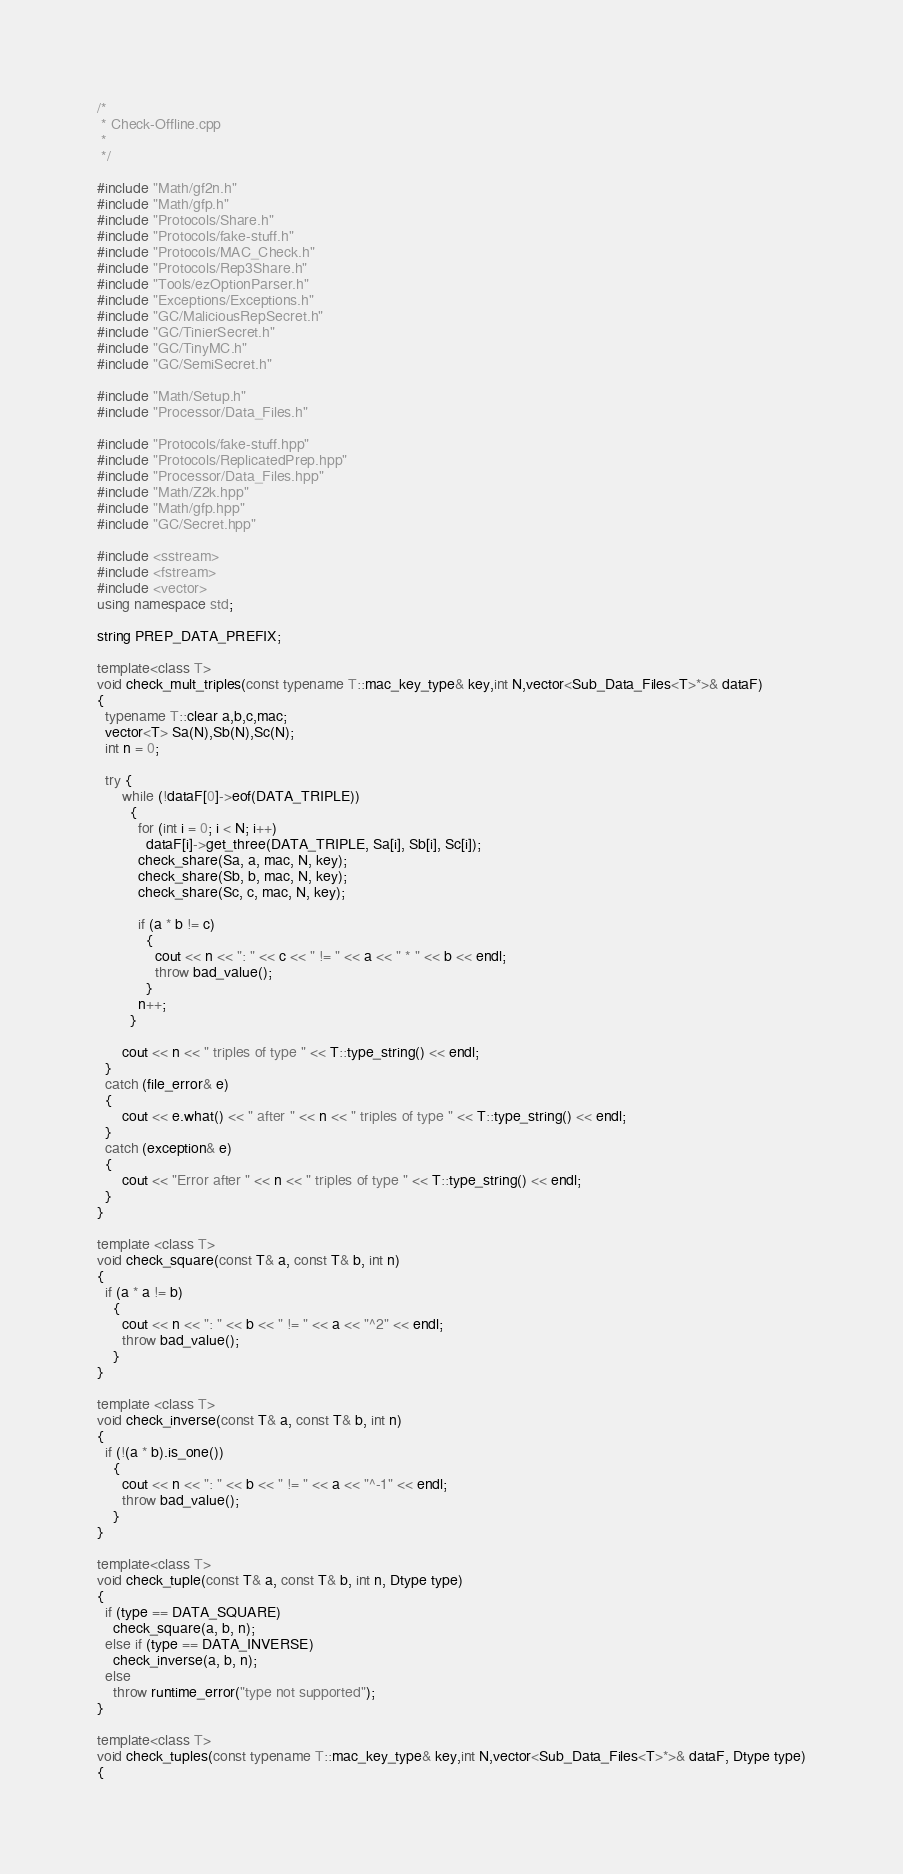Convert code to text. <code><loc_0><loc_0><loc_500><loc_500><_C++_>/*
 * Check-Offline.cpp
 *
 */

#include "Math/gf2n.h"
#include "Math/gfp.h"
#include "Protocols/Share.h"
#include "Protocols/fake-stuff.h"
#include "Protocols/MAC_Check.h"
#include "Protocols/Rep3Share.h"
#include "Tools/ezOptionParser.h"
#include "Exceptions/Exceptions.h"
#include "GC/MaliciousRepSecret.h"
#include "GC/TinierSecret.h"
#include "GC/TinyMC.h"
#include "GC/SemiSecret.h"

#include "Math/Setup.h"
#include "Processor/Data_Files.h"

#include "Protocols/fake-stuff.hpp"
#include "Protocols/ReplicatedPrep.hpp"
#include "Processor/Data_Files.hpp"
#include "Math/Z2k.hpp"
#include "Math/gfp.hpp"
#include "GC/Secret.hpp"

#include <sstream>
#include <fstream>
#include <vector>
using namespace std;

string PREP_DATA_PREFIX;

template<class T>
void check_mult_triples(const typename T::mac_key_type& key,int N,vector<Sub_Data_Files<T>*>& dataF)
{
  typename T::clear a,b,c,mac;
  vector<T> Sa(N),Sb(N),Sc(N);
  int n = 0;

  try {
      while (!dataF[0]->eof(DATA_TRIPLE))
        {
          for (int i = 0; i < N; i++)
            dataF[i]->get_three(DATA_TRIPLE, Sa[i], Sb[i], Sc[i]);
          check_share(Sa, a, mac, N, key);
          check_share(Sb, b, mac, N, key);
          check_share(Sc, c, mac, N, key);

          if (a * b != c)
            {
              cout << n << ": " << c << " != " << a << " * " << b << endl;
              throw bad_value();
            }
          n++;
        }

      cout << n << " triples of type " << T::type_string() << endl;
  }
  catch (file_error& e)
  {
      cout << e.what() << " after " << n << " triples of type " << T::type_string() << endl;
  }
  catch (exception& e)
  {
      cout << "Error after " << n << " triples of type " << T::type_string() << endl;
  }
}

template <class T>
void check_square(const T& a, const T& b, int n)
{
  if (a * a != b)
    {
      cout << n << ": " << b << " != " << a << "^2" << endl;
      throw bad_value();
    }
}

template <class T>
void check_inverse(const T& a, const T& b, int n)
{
  if (!(a * b).is_one())
    {
      cout << n << ": " << b << " != " << a << "^-1" << endl;
      throw bad_value();
    }
}

template<class T>
void check_tuple(const T& a, const T& b, int n, Dtype type)
{
  if (type == DATA_SQUARE)
    check_square(a, b, n);
  else if (type == DATA_INVERSE)
    check_inverse(a, b, n);
  else
    throw runtime_error("type not supported");
}

template<class T>
void check_tuples(const typename T::mac_key_type& key,int N,vector<Sub_Data_Files<T>*>& dataF, Dtype type)
{</code> 